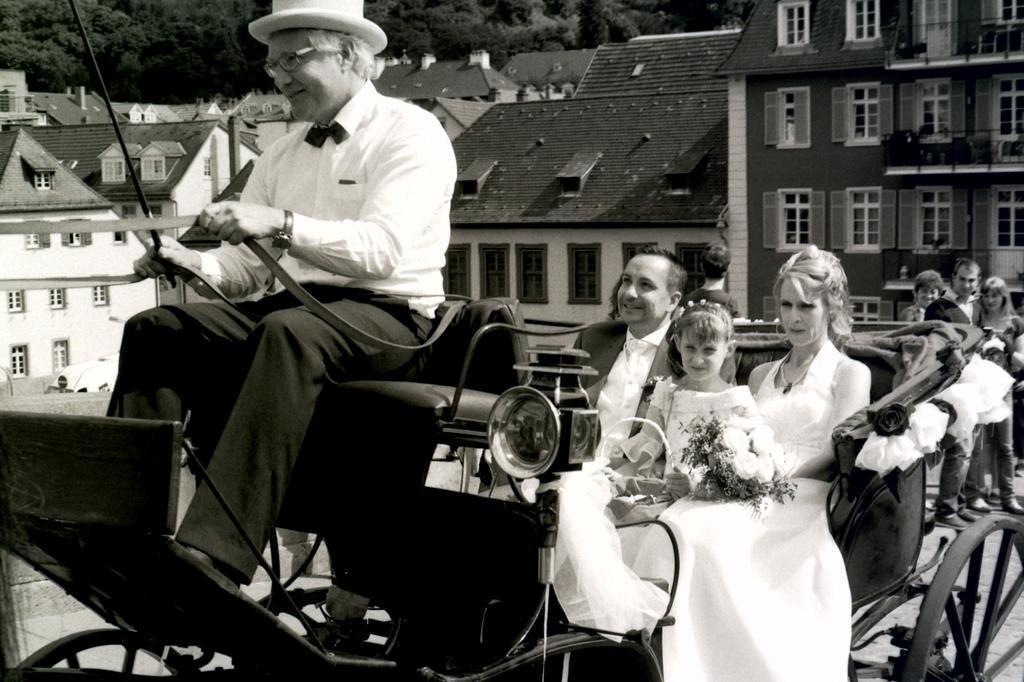Please provide a concise description of this image. In this picture I can see a cart on which I can see 2 men, a girl and a woman who are sitting and I see that the man on the left is holding a stick and the belt in his hands and the woman is holding a bouquet. In the background I can see number of buildings and the trees. On the right side of this picture I can see 3 persons. I see that this is a black and white image. 